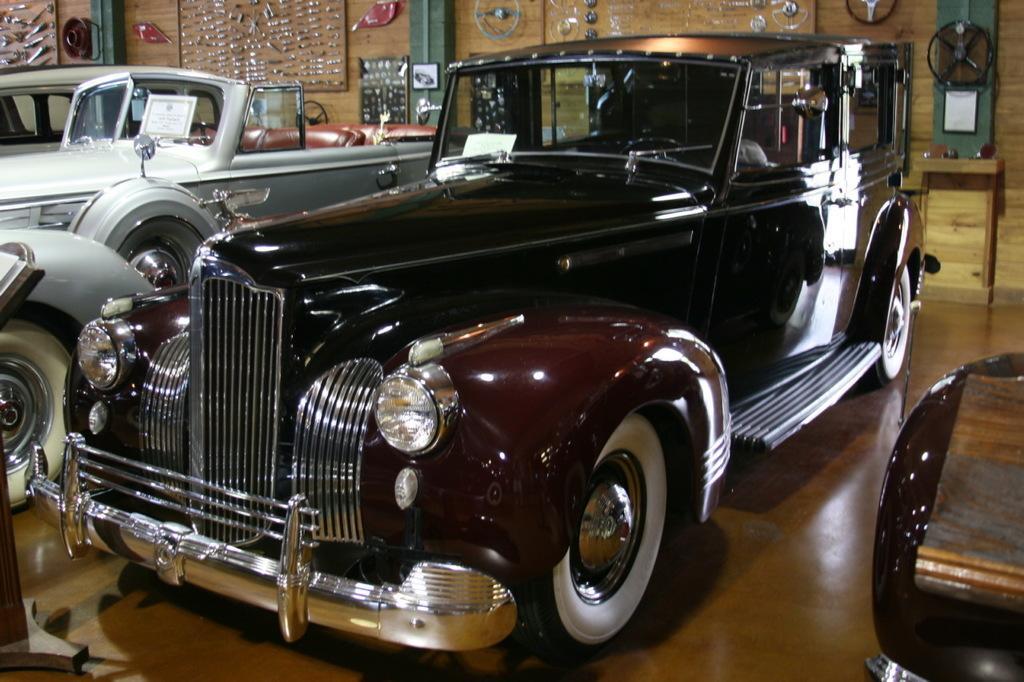Please provide a concise description of this image. In this picture I can observe cars parked on the floor. In the background I can observe steering wheels and wrenches on the wall. 